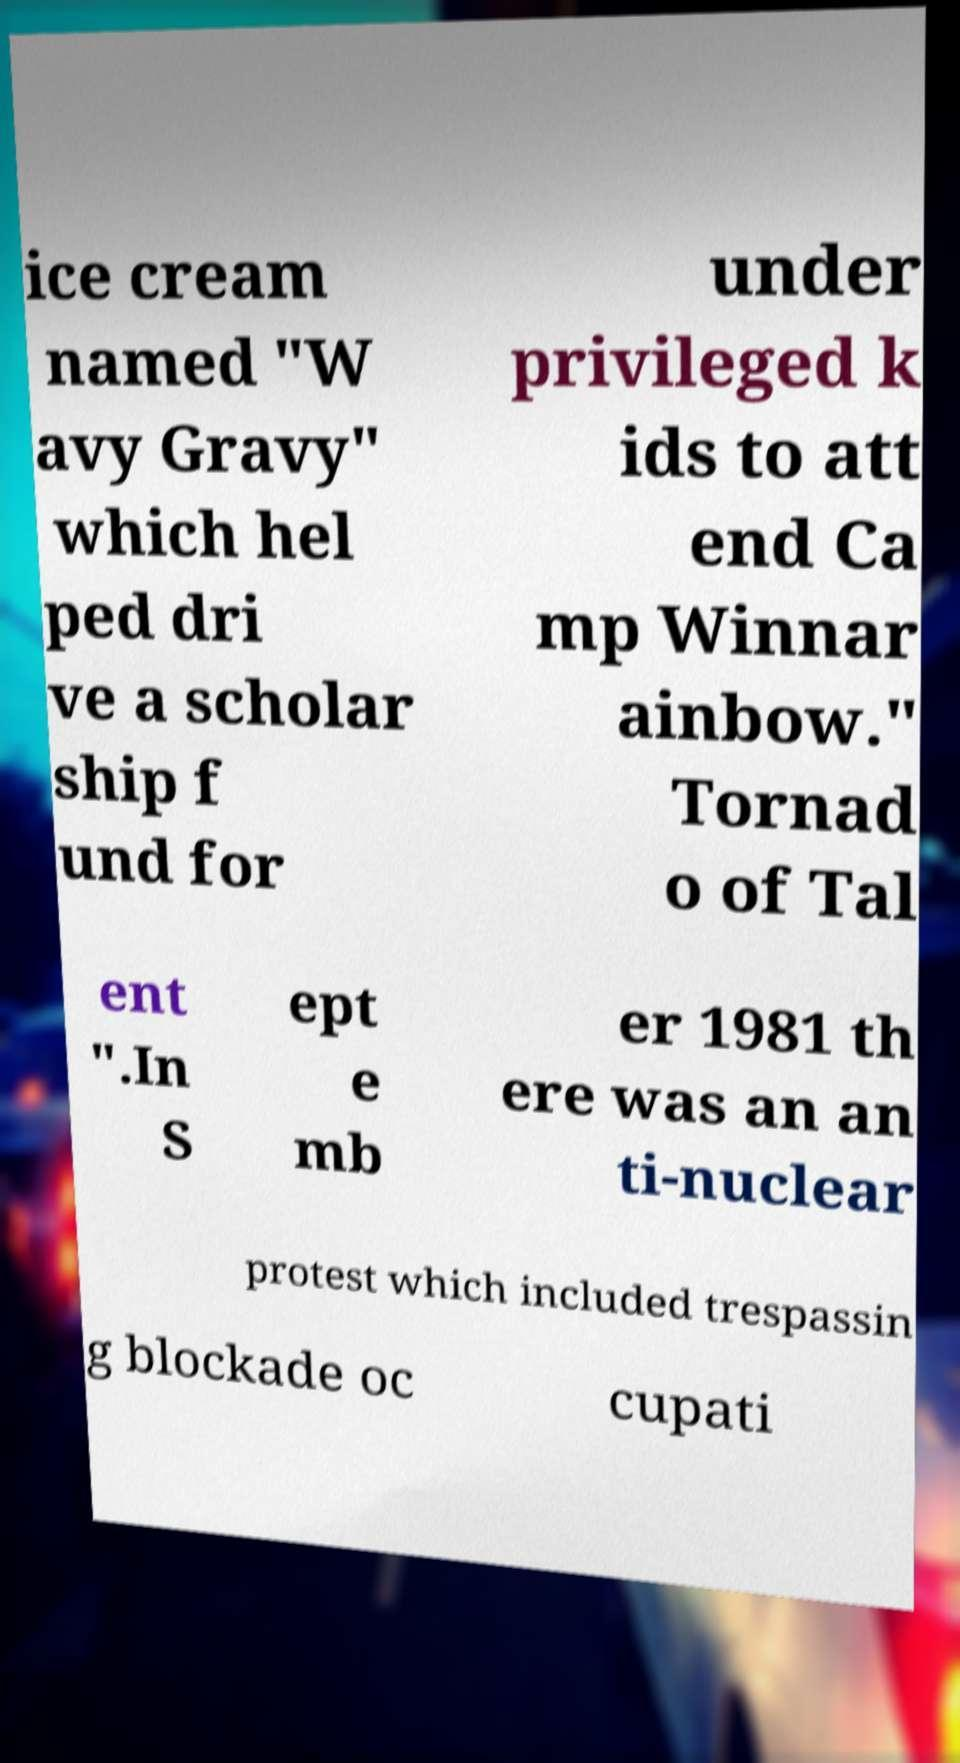Can you read and provide the text displayed in the image?This photo seems to have some interesting text. Can you extract and type it out for me? ice cream named "W avy Gravy" which hel ped dri ve a scholar ship f und for under privileged k ids to att end Ca mp Winnar ainbow." Tornad o of Tal ent ".In S ept e mb er 1981 th ere was an an ti-nuclear protest which included trespassin g blockade oc cupati 